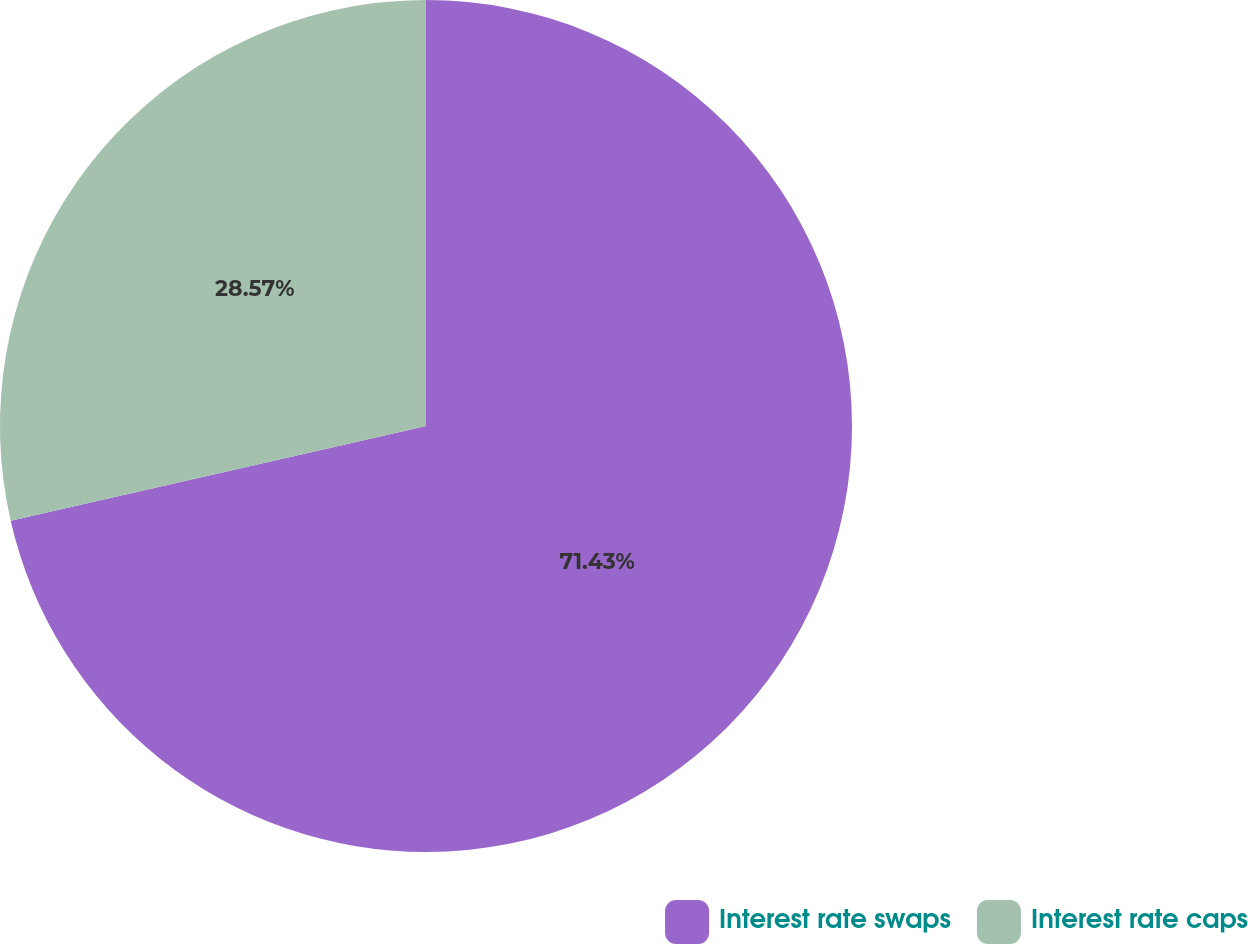Convert chart. <chart><loc_0><loc_0><loc_500><loc_500><pie_chart><fcel>Interest rate swaps<fcel>Interest rate caps<nl><fcel>71.43%<fcel>28.57%<nl></chart> 